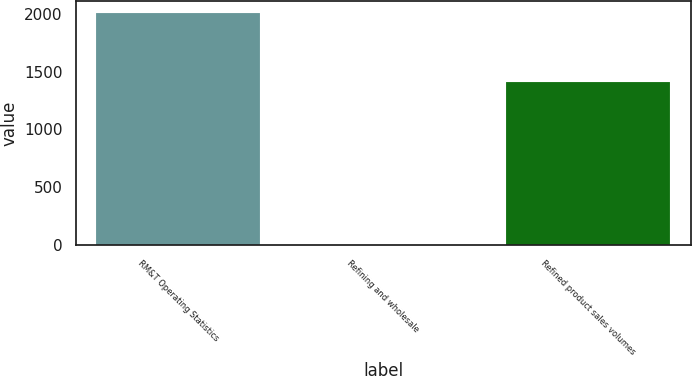Convert chart to OTSL. <chart><loc_0><loc_0><loc_500><loc_500><bar_chart><fcel>RM&T Operating Statistics<fcel>Refining and wholesale<fcel>Refined product sales volumes<nl><fcel>2007<fcel>0.18<fcel>1410<nl></chart> 